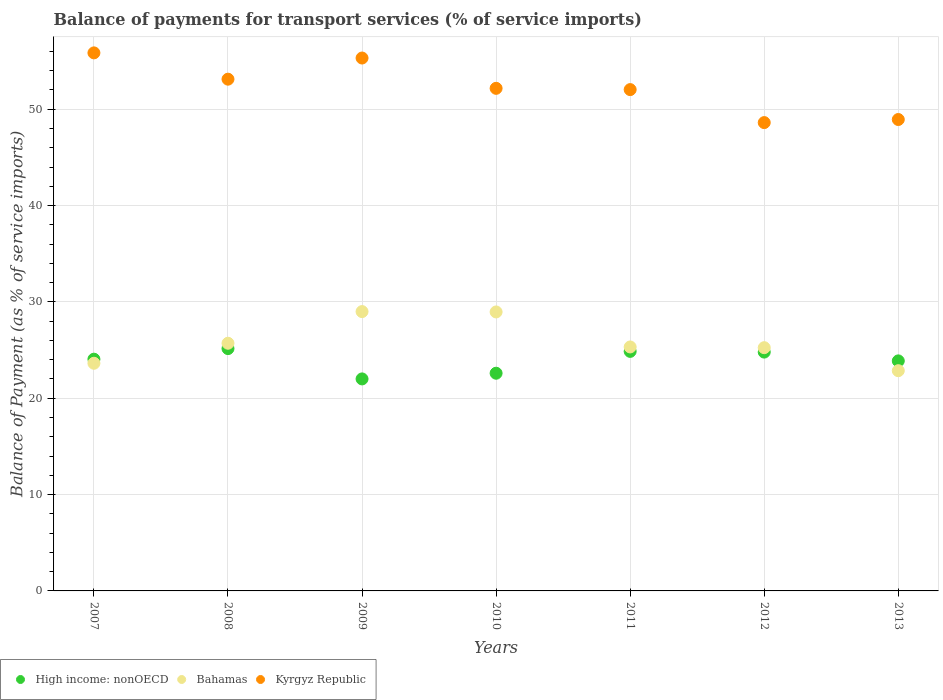How many different coloured dotlines are there?
Give a very brief answer. 3. Is the number of dotlines equal to the number of legend labels?
Your response must be concise. Yes. What is the balance of payments for transport services in Bahamas in 2007?
Offer a terse response. 23.63. Across all years, what is the maximum balance of payments for transport services in Bahamas?
Offer a very short reply. 29. Across all years, what is the minimum balance of payments for transport services in High income: nonOECD?
Provide a short and direct response. 22.01. In which year was the balance of payments for transport services in Kyrgyz Republic maximum?
Keep it short and to the point. 2007. What is the total balance of payments for transport services in Bahamas in the graph?
Your response must be concise. 180.73. What is the difference between the balance of payments for transport services in Bahamas in 2007 and that in 2011?
Your answer should be very brief. -1.69. What is the difference between the balance of payments for transport services in Bahamas in 2009 and the balance of payments for transport services in Kyrgyz Republic in 2012?
Offer a terse response. -19.62. What is the average balance of payments for transport services in Bahamas per year?
Your answer should be very brief. 25.82. In the year 2011, what is the difference between the balance of payments for transport services in High income: nonOECD and balance of payments for transport services in Kyrgyz Republic?
Your answer should be very brief. -27.17. In how many years, is the balance of payments for transport services in Bahamas greater than 16 %?
Keep it short and to the point. 7. What is the ratio of the balance of payments for transport services in Bahamas in 2007 to that in 2008?
Offer a terse response. 0.92. What is the difference between the highest and the second highest balance of payments for transport services in High income: nonOECD?
Offer a very short reply. 0.29. What is the difference between the highest and the lowest balance of payments for transport services in Kyrgyz Republic?
Your response must be concise. 7.24. In how many years, is the balance of payments for transport services in High income: nonOECD greater than the average balance of payments for transport services in High income: nonOECD taken over all years?
Make the answer very short. 4. Is the sum of the balance of payments for transport services in Kyrgyz Republic in 2008 and 2013 greater than the maximum balance of payments for transport services in High income: nonOECD across all years?
Offer a terse response. Yes. Is the balance of payments for transport services in Kyrgyz Republic strictly greater than the balance of payments for transport services in High income: nonOECD over the years?
Your response must be concise. Yes. Is the balance of payments for transport services in Kyrgyz Republic strictly less than the balance of payments for transport services in Bahamas over the years?
Your answer should be compact. No. How many dotlines are there?
Offer a terse response. 3. What is the difference between two consecutive major ticks on the Y-axis?
Give a very brief answer. 10. Are the values on the major ticks of Y-axis written in scientific E-notation?
Make the answer very short. No. Does the graph contain any zero values?
Give a very brief answer. No. Does the graph contain grids?
Keep it short and to the point. Yes. What is the title of the graph?
Your answer should be very brief. Balance of payments for transport services (% of service imports). What is the label or title of the Y-axis?
Make the answer very short. Balance of Payment (as % of service imports). What is the Balance of Payment (as % of service imports) in High income: nonOECD in 2007?
Offer a terse response. 24.06. What is the Balance of Payment (as % of service imports) in Bahamas in 2007?
Your response must be concise. 23.63. What is the Balance of Payment (as % of service imports) of Kyrgyz Republic in 2007?
Provide a short and direct response. 55.85. What is the Balance of Payment (as % of service imports) in High income: nonOECD in 2008?
Offer a terse response. 25.15. What is the Balance of Payment (as % of service imports) of Bahamas in 2008?
Your answer should be compact. 25.71. What is the Balance of Payment (as % of service imports) of Kyrgyz Republic in 2008?
Offer a terse response. 53.12. What is the Balance of Payment (as % of service imports) in High income: nonOECD in 2009?
Provide a short and direct response. 22.01. What is the Balance of Payment (as % of service imports) of Bahamas in 2009?
Provide a short and direct response. 29. What is the Balance of Payment (as % of service imports) in Kyrgyz Republic in 2009?
Make the answer very short. 55.32. What is the Balance of Payment (as % of service imports) of High income: nonOECD in 2010?
Give a very brief answer. 22.6. What is the Balance of Payment (as % of service imports) in Bahamas in 2010?
Make the answer very short. 28.96. What is the Balance of Payment (as % of service imports) in Kyrgyz Republic in 2010?
Your answer should be compact. 52.17. What is the Balance of Payment (as % of service imports) in High income: nonOECD in 2011?
Offer a very short reply. 24.86. What is the Balance of Payment (as % of service imports) in Bahamas in 2011?
Give a very brief answer. 25.32. What is the Balance of Payment (as % of service imports) in Kyrgyz Republic in 2011?
Make the answer very short. 52.04. What is the Balance of Payment (as % of service imports) in High income: nonOECD in 2012?
Your answer should be very brief. 24.79. What is the Balance of Payment (as % of service imports) of Bahamas in 2012?
Provide a short and direct response. 25.25. What is the Balance of Payment (as % of service imports) of Kyrgyz Republic in 2012?
Your response must be concise. 48.61. What is the Balance of Payment (as % of service imports) of High income: nonOECD in 2013?
Give a very brief answer. 23.88. What is the Balance of Payment (as % of service imports) in Bahamas in 2013?
Provide a short and direct response. 22.86. What is the Balance of Payment (as % of service imports) in Kyrgyz Republic in 2013?
Make the answer very short. 48.93. Across all years, what is the maximum Balance of Payment (as % of service imports) of High income: nonOECD?
Provide a succinct answer. 25.15. Across all years, what is the maximum Balance of Payment (as % of service imports) of Bahamas?
Your answer should be compact. 29. Across all years, what is the maximum Balance of Payment (as % of service imports) in Kyrgyz Republic?
Keep it short and to the point. 55.85. Across all years, what is the minimum Balance of Payment (as % of service imports) of High income: nonOECD?
Your answer should be very brief. 22.01. Across all years, what is the minimum Balance of Payment (as % of service imports) of Bahamas?
Your answer should be very brief. 22.86. Across all years, what is the minimum Balance of Payment (as % of service imports) in Kyrgyz Republic?
Provide a succinct answer. 48.61. What is the total Balance of Payment (as % of service imports) of High income: nonOECD in the graph?
Offer a terse response. 167.35. What is the total Balance of Payment (as % of service imports) of Bahamas in the graph?
Provide a succinct answer. 180.73. What is the total Balance of Payment (as % of service imports) of Kyrgyz Republic in the graph?
Offer a very short reply. 366.04. What is the difference between the Balance of Payment (as % of service imports) of High income: nonOECD in 2007 and that in 2008?
Provide a short and direct response. -1.1. What is the difference between the Balance of Payment (as % of service imports) in Bahamas in 2007 and that in 2008?
Provide a succinct answer. -2.08. What is the difference between the Balance of Payment (as % of service imports) of Kyrgyz Republic in 2007 and that in 2008?
Make the answer very short. 2.73. What is the difference between the Balance of Payment (as % of service imports) in High income: nonOECD in 2007 and that in 2009?
Your response must be concise. 2.05. What is the difference between the Balance of Payment (as % of service imports) of Bahamas in 2007 and that in 2009?
Offer a very short reply. -5.36. What is the difference between the Balance of Payment (as % of service imports) in Kyrgyz Republic in 2007 and that in 2009?
Provide a succinct answer. 0.53. What is the difference between the Balance of Payment (as % of service imports) in High income: nonOECD in 2007 and that in 2010?
Your answer should be compact. 1.46. What is the difference between the Balance of Payment (as % of service imports) in Bahamas in 2007 and that in 2010?
Provide a short and direct response. -5.33. What is the difference between the Balance of Payment (as % of service imports) in Kyrgyz Republic in 2007 and that in 2010?
Give a very brief answer. 3.68. What is the difference between the Balance of Payment (as % of service imports) in High income: nonOECD in 2007 and that in 2011?
Offer a terse response. -0.81. What is the difference between the Balance of Payment (as % of service imports) of Bahamas in 2007 and that in 2011?
Make the answer very short. -1.69. What is the difference between the Balance of Payment (as % of service imports) of Kyrgyz Republic in 2007 and that in 2011?
Provide a short and direct response. 3.81. What is the difference between the Balance of Payment (as % of service imports) of High income: nonOECD in 2007 and that in 2012?
Keep it short and to the point. -0.74. What is the difference between the Balance of Payment (as % of service imports) of Bahamas in 2007 and that in 2012?
Provide a short and direct response. -1.62. What is the difference between the Balance of Payment (as % of service imports) in Kyrgyz Republic in 2007 and that in 2012?
Keep it short and to the point. 7.24. What is the difference between the Balance of Payment (as % of service imports) of High income: nonOECD in 2007 and that in 2013?
Provide a short and direct response. 0.18. What is the difference between the Balance of Payment (as % of service imports) of Bahamas in 2007 and that in 2013?
Your answer should be compact. 0.77. What is the difference between the Balance of Payment (as % of service imports) of Kyrgyz Republic in 2007 and that in 2013?
Give a very brief answer. 6.92. What is the difference between the Balance of Payment (as % of service imports) in High income: nonOECD in 2008 and that in 2009?
Your answer should be compact. 3.15. What is the difference between the Balance of Payment (as % of service imports) in Bahamas in 2008 and that in 2009?
Ensure brevity in your answer.  -3.29. What is the difference between the Balance of Payment (as % of service imports) of Kyrgyz Republic in 2008 and that in 2009?
Offer a terse response. -2.19. What is the difference between the Balance of Payment (as % of service imports) in High income: nonOECD in 2008 and that in 2010?
Offer a terse response. 2.56. What is the difference between the Balance of Payment (as % of service imports) of Bahamas in 2008 and that in 2010?
Ensure brevity in your answer.  -3.25. What is the difference between the Balance of Payment (as % of service imports) of Kyrgyz Republic in 2008 and that in 2010?
Your answer should be compact. 0.95. What is the difference between the Balance of Payment (as % of service imports) of High income: nonOECD in 2008 and that in 2011?
Give a very brief answer. 0.29. What is the difference between the Balance of Payment (as % of service imports) in Bahamas in 2008 and that in 2011?
Your answer should be compact. 0.39. What is the difference between the Balance of Payment (as % of service imports) in Kyrgyz Republic in 2008 and that in 2011?
Keep it short and to the point. 1.08. What is the difference between the Balance of Payment (as % of service imports) of High income: nonOECD in 2008 and that in 2012?
Provide a short and direct response. 0.36. What is the difference between the Balance of Payment (as % of service imports) of Bahamas in 2008 and that in 2012?
Give a very brief answer. 0.46. What is the difference between the Balance of Payment (as % of service imports) in Kyrgyz Republic in 2008 and that in 2012?
Provide a short and direct response. 4.51. What is the difference between the Balance of Payment (as % of service imports) in High income: nonOECD in 2008 and that in 2013?
Provide a short and direct response. 1.27. What is the difference between the Balance of Payment (as % of service imports) in Bahamas in 2008 and that in 2013?
Your answer should be compact. 2.85. What is the difference between the Balance of Payment (as % of service imports) of Kyrgyz Republic in 2008 and that in 2013?
Keep it short and to the point. 4.19. What is the difference between the Balance of Payment (as % of service imports) of High income: nonOECD in 2009 and that in 2010?
Provide a succinct answer. -0.59. What is the difference between the Balance of Payment (as % of service imports) in Bahamas in 2009 and that in 2010?
Make the answer very short. 0.04. What is the difference between the Balance of Payment (as % of service imports) in Kyrgyz Republic in 2009 and that in 2010?
Offer a terse response. 3.15. What is the difference between the Balance of Payment (as % of service imports) of High income: nonOECD in 2009 and that in 2011?
Your response must be concise. -2.86. What is the difference between the Balance of Payment (as % of service imports) of Bahamas in 2009 and that in 2011?
Give a very brief answer. 3.67. What is the difference between the Balance of Payment (as % of service imports) of Kyrgyz Republic in 2009 and that in 2011?
Offer a terse response. 3.28. What is the difference between the Balance of Payment (as % of service imports) of High income: nonOECD in 2009 and that in 2012?
Your answer should be very brief. -2.78. What is the difference between the Balance of Payment (as % of service imports) of Bahamas in 2009 and that in 2012?
Provide a short and direct response. 3.75. What is the difference between the Balance of Payment (as % of service imports) of Kyrgyz Republic in 2009 and that in 2012?
Ensure brevity in your answer.  6.7. What is the difference between the Balance of Payment (as % of service imports) of High income: nonOECD in 2009 and that in 2013?
Keep it short and to the point. -1.87. What is the difference between the Balance of Payment (as % of service imports) of Bahamas in 2009 and that in 2013?
Provide a short and direct response. 6.14. What is the difference between the Balance of Payment (as % of service imports) of Kyrgyz Republic in 2009 and that in 2013?
Ensure brevity in your answer.  6.38. What is the difference between the Balance of Payment (as % of service imports) in High income: nonOECD in 2010 and that in 2011?
Your answer should be compact. -2.27. What is the difference between the Balance of Payment (as % of service imports) in Bahamas in 2010 and that in 2011?
Keep it short and to the point. 3.63. What is the difference between the Balance of Payment (as % of service imports) of Kyrgyz Republic in 2010 and that in 2011?
Keep it short and to the point. 0.13. What is the difference between the Balance of Payment (as % of service imports) of High income: nonOECD in 2010 and that in 2012?
Your answer should be compact. -2.19. What is the difference between the Balance of Payment (as % of service imports) in Bahamas in 2010 and that in 2012?
Your response must be concise. 3.71. What is the difference between the Balance of Payment (as % of service imports) of Kyrgyz Republic in 2010 and that in 2012?
Your answer should be compact. 3.56. What is the difference between the Balance of Payment (as % of service imports) of High income: nonOECD in 2010 and that in 2013?
Provide a succinct answer. -1.28. What is the difference between the Balance of Payment (as % of service imports) of Bahamas in 2010 and that in 2013?
Ensure brevity in your answer.  6.1. What is the difference between the Balance of Payment (as % of service imports) of Kyrgyz Republic in 2010 and that in 2013?
Make the answer very short. 3.24. What is the difference between the Balance of Payment (as % of service imports) in High income: nonOECD in 2011 and that in 2012?
Your answer should be very brief. 0.07. What is the difference between the Balance of Payment (as % of service imports) in Bahamas in 2011 and that in 2012?
Provide a short and direct response. 0.08. What is the difference between the Balance of Payment (as % of service imports) of Kyrgyz Republic in 2011 and that in 2012?
Keep it short and to the point. 3.43. What is the difference between the Balance of Payment (as % of service imports) in High income: nonOECD in 2011 and that in 2013?
Provide a succinct answer. 0.99. What is the difference between the Balance of Payment (as % of service imports) in Bahamas in 2011 and that in 2013?
Provide a succinct answer. 2.46. What is the difference between the Balance of Payment (as % of service imports) of Kyrgyz Republic in 2011 and that in 2013?
Make the answer very short. 3.1. What is the difference between the Balance of Payment (as % of service imports) in High income: nonOECD in 2012 and that in 2013?
Your answer should be compact. 0.91. What is the difference between the Balance of Payment (as % of service imports) in Bahamas in 2012 and that in 2013?
Offer a very short reply. 2.39. What is the difference between the Balance of Payment (as % of service imports) of Kyrgyz Republic in 2012 and that in 2013?
Give a very brief answer. -0.32. What is the difference between the Balance of Payment (as % of service imports) in High income: nonOECD in 2007 and the Balance of Payment (as % of service imports) in Bahamas in 2008?
Make the answer very short. -1.65. What is the difference between the Balance of Payment (as % of service imports) in High income: nonOECD in 2007 and the Balance of Payment (as % of service imports) in Kyrgyz Republic in 2008?
Provide a succinct answer. -29.07. What is the difference between the Balance of Payment (as % of service imports) of Bahamas in 2007 and the Balance of Payment (as % of service imports) of Kyrgyz Republic in 2008?
Make the answer very short. -29.49. What is the difference between the Balance of Payment (as % of service imports) in High income: nonOECD in 2007 and the Balance of Payment (as % of service imports) in Bahamas in 2009?
Keep it short and to the point. -4.94. What is the difference between the Balance of Payment (as % of service imports) in High income: nonOECD in 2007 and the Balance of Payment (as % of service imports) in Kyrgyz Republic in 2009?
Provide a short and direct response. -31.26. What is the difference between the Balance of Payment (as % of service imports) in Bahamas in 2007 and the Balance of Payment (as % of service imports) in Kyrgyz Republic in 2009?
Your answer should be very brief. -31.68. What is the difference between the Balance of Payment (as % of service imports) of High income: nonOECD in 2007 and the Balance of Payment (as % of service imports) of Bahamas in 2010?
Provide a short and direct response. -4.9. What is the difference between the Balance of Payment (as % of service imports) of High income: nonOECD in 2007 and the Balance of Payment (as % of service imports) of Kyrgyz Republic in 2010?
Provide a short and direct response. -28.11. What is the difference between the Balance of Payment (as % of service imports) of Bahamas in 2007 and the Balance of Payment (as % of service imports) of Kyrgyz Republic in 2010?
Ensure brevity in your answer.  -28.54. What is the difference between the Balance of Payment (as % of service imports) in High income: nonOECD in 2007 and the Balance of Payment (as % of service imports) in Bahamas in 2011?
Your response must be concise. -1.27. What is the difference between the Balance of Payment (as % of service imports) of High income: nonOECD in 2007 and the Balance of Payment (as % of service imports) of Kyrgyz Republic in 2011?
Keep it short and to the point. -27.98. What is the difference between the Balance of Payment (as % of service imports) of Bahamas in 2007 and the Balance of Payment (as % of service imports) of Kyrgyz Republic in 2011?
Ensure brevity in your answer.  -28.41. What is the difference between the Balance of Payment (as % of service imports) in High income: nonOECD in 2007 and the Balance of Payment (as % of service imports) in Bahamas in 2012?
Make the answer very short. -1.19. What is the difference between the Balance of Payment (as % of service imports) in High income: nonOECD in 2007 and the Balance of Payment (as % of service imports) in Kyrgyz Republic in 2012?
Make the answer very short. -24.56. What is the difference between the Balance of Payment (as % of service imports) in Bahamas in 2007 and the Balance of Payment (as % of service imports) in Kyrgyz Republic in 2012?
Your answer should be compact. -24.98. What is the difference between the Balance of Payment (as % of service imports) in High income: nonOECD in 2007 and the Balance of Payment (as % of service imports) in Bahamas in 2013?
Give a very brief answer. 1.19. What is the difference between the Balance of Payment (as % of service imports) of High income: nonOECD in 2007 and the Balance of Payment (as % of service imports) of Kyrgyz Republic in 2013?
Ensure brevity in your answer.  -24.88. What is the difference between the Balance of Payment (as % of service imports) of Bahamas in 2007 and the Balance of Payment (as % of service imports) of Kyrgyz Republic in 2013?
Keep it short and to the point. -25.3. What is the difference between the Balance of Payment (as % of service imports) in High income: nonOECD in 2008 and the Balance of Payment (as % of service imports) in Bahamas in 2009?
Offer a very short reply. -3.84. What is the difference between the Balance of Payment (as % of service imports) in High income: nonOECD in 2008 and the Balance of Payment (as % of service imports) in Kyrgyz Republic in 2009?
Make the answer very short. -30.16. What is the difference between the Balance of Payment (as % of service imports) in Bahamas in 2008 and the Balance of Payment (as % of service imports) in Kyrgyz Republic in 2009?
Offer a terse response. -29.61. What is the difference between the Balance of Payment (as % of service imports) in High income: nonOECD in 2008 and the Balance of Payment (as % of service imports) in Bahamas in 2010?
Offer a very short reply. -3.81. What is the difference between the Balance of Payment (as % of service imports) of High income: nonOECD in 2008 and the Balance of Payment (as % of service imports) of Kyrgyz Republic in 2010?
Offer a terse response. -27.02. What is the difference between the Balance of Payment (as % of service imports) in Bahamas in 2008 and the Balance of Payment (as % of service imports) in Kyrgyz Republic in 2010?
Offer a terse response. -26.46. What is the difference between the Balance of Payment (as % of service imports) of High income: nonOECD in 2008 and the Balance of Payment (as % of service imports) of Bahamas in 2011?
Offer a very short reply. -0.17. What is the difference between the Balance of Payment (as % of service imports) in High income: nonOECD in 2008 and the Balance of Payment (as % of service imports) in Kyrgyz Republic in 2011?
Your answer should be very brief. -26.89. What is the difference between the Balance of Payment (as % of service imports) in Bahamas in 2008 and the Balance of Payment (as % of service imports) in Kyrgyz Republic in 2011?
Your answer should be very brief. -26.33. What is the difference between the Balance of Payment (as % of service imports) in High income: nonOECD in 2008 and the Balance of Payment (as % of service imports) in Bahamas in 2012?
Your answer should be very brief. -0.1. What is the difference between the Balance of Payment (as % of service imports) in High income: nonOECD in 2008 and the Balance of Payment (as % of service imports) in Kyrgyz Republic in 2012?
Provide a succinct answer. -23.46. What is the difference between the Balance of Payment (as % of service imports) in Bahamas in 2008 and the Balance of Payment (as % of service imports) in Kyrgyz Republic in 2012?
Provide a succinct answer. -22.9. What is the difference between the Balance of Payment (as % of service imports) in High income: nonOECD in 2008 and the Balance of Payment (as % of service imports) in Bahamas in 2013?
Offer a terse response. 2.29. What is the difference between the Balance of Payment (as % of service imports) of High income: nonOECD in 2008 and the Balance of Payment (as % of service imports) of Kyrgyz Republic in 2013?
Offer a very short reply. -23.78. What is the difference between the Balance of Payment (as % of service imports) in Bahamas in 2008 and the Balance of Payment (as % of service imports) in Kyrgyz Republic in 2013?
Provide a short and direct response. -23.22. What is the difference between the Balance of Payment (as % of service imports) of High income: nonOECD in 2009 and the Balance of Payment (as % of service imports) of Bahamas in 2010?
Your answer should be compact. -6.95. What is the difference between the Balance of Payment (as % of service imports) in High income: nonOECD in 2009 and the Balance of Payment (as % of service imports) in Kyrgyz Republic in 2010?
Provide a succinct answer. -30.16. What is the difference between the Balance of Payment (as % of service imports) of Bahamas in 2009 and the Balance of Payment (as % of service imports) of Kyrgyz Republic in 2010?
Provide a short and direct response. -23.17. What is the difference between the Balance of Payment (as % of service imports) of High income: nonOECD in 2009 and the Balance of Payment (as % of service imports) of Bahamas in 2011?
Provide a succinct answer. -3.32. What is the difference between the Balance of Payment (as % of service imports) of High income: nonOECD in 2009 and the Balance of Payment (as % of service imports) of Kyrgyz Republic in 2011?
Keep it short and to the point. -30.03. What is the difference between the Balance of Payment (as % of service imports) in Bahamas in 2009 and the Balance of Payment (as % of service imports) in Kyrgyz Republic in 2011?
Provide a succinct answer. -23.04. What is the difference between the Balance of Payment (as % of service imports) of High income: nonOECD in 2009 and the Balance of Payment (as % of service imports) of Bahamas in 2012?
Keep it short and to the point. -3.24. What is the difference between the Balance of Payment (as % of service imports) of High income: nonOECD in 2009 and the Balance of Payment (as % of service imports) of Kyrgyz Republic in 2012?
Offer a terse response. -26.61. What is the difference between the Balance of Payment (as % of service imports) of Bahamas in 2009 and the Balance of Payment (as % of service imports) of Kyrgyz Republic in 2012?
Make the answer very short. -19.62. What is the difference between the Balance of Payment (as % of service imports) of High income: nonOECD in 2009 and the Balance of Payment (as % of service imports) of Bahamas in 2013?
Ensure brevity in your answer.  -0.85. What is the difference between the Balance of Payment (as % of service imports) in High income: nonOECD in 2009 and the Balance of Payment (as % of service imports) in Kyrgyz Republic in 2013?
Give a very brief answer. -26.93. What is the difference between the Balance of Payment (as % of service imports) in Bahamas in 2009 and the Balance of Payment (as % of service imports) in Kyrgyz Republic in 2013?
Offer a very short reply. -19.94. What is the difference between the Balance of Payment (as % of service imports) in High income: nonOECD in 2010 and the Balance of Payment (as % of service imports) in Bahamas in 2011?
Give a very brief answer. -2.73. What is the difference between the Balance of Payment (as % of service imports) in High income: nonOECD in 2010 and the Balance of Payment (as % of service imports) in Kyrgyz Republic in 2011?
Ensure brevity in your answer.  -29.44. What is the difference between the Balance of Payment (as % of service imports) in Bahamas in 2010 and the Balance of Payment (as % of service imports) in Kyrgyz Republic in 2011?
Your response must be concise. -23.08. What is the difference between the Balance of Payment (as % of service imports) of High income: nonOECD in 2010 and the Balance of Payment (as % of service imports) of Bahamas in 2012?
Keep it short and to the point. -2.65. What is the difference between the Balance of Payment (as % of service imports) in High income: nonOECD in 2010 and the Balance of Payment (as % of service imports) in Kyrgyz Republic in 2012?
Your answer should be compact. -26.02. What is the difference between the Balance of Payment (as % of service imports) of Bahamas in 2010 and the Balance of Payment (as % of service imports) of Kyrgyz Republic in 2012?
Ensure brevity in your answer.  -19.66. What is the difference between the Balance of Payment (as % of service imports) in High income: nonOECD in 2010 and the Balance of Payment (as % of service imports) in Bahamas in 2013?
Provide a short and direct response. -0.26. What is the difference between the Balance of Payment (as % of service imports) of High income: nonOECD in 2010 and the Balance of Payment (as % of service imports) of Kyrgyz Republic in 2013?
Offer a very short reply. -26.34. What is the difference between the Balance of Payment (as % of service imports) in Bahamas in 2010 and the Balance of Payment (as % of service imports) in Kyrgyz Republic in 2013?
Provide a short and direct response. -19.98. What is the difference between the Balance of Payment (as % of service imports) in High income: nonOECD in 2011 and the Balance of Payment (as % of service imports) in Bahamas in 2012?
Make the answer very short. -0.39. What is the difference between the Balance of Payment (as % of service imports) in High income: nonOECD in 2011 and the Balance of Payment (as % of service imports) in Kyrgyz Republic in 2012?
Provide a short and direct response. -23.75. What is the difference between the Balance of Payment (as % of service imports) of Bahamas in 2011 and the Balance of Payment (as % of service imports) of Kyrgyz Republic in 2012?
Give a very brief answer. -23.29. What is the difference between the Balance of Payment (as % of service imports) in High income: nonOECD in 2011 and the Balance of Payment (as % of service imports) in Bahamas in 2013?
Keep it short and to the point. 2. What is the difference between the Balance of Payment (as % of service imports) of High income: nonOECD in 2011 and the Balance of Payment (as % of service imports) of Kyrgyz Republic in 2013?
Offer a very short reply. -24.07. What is the difference between the Balance of Payment (as % of service imports) in Bahamas in 2011 and the Balance of Payment (as % of service imports) in Kyrgyz Republic in 2013?
Your answer should be very brief. -23.61. What is the difference between the Balance of Payment (as % of service imports) in High income: nonOECD in 2012 and the Balance of Payment (as % of service imports) in Bahamas in 2013?
Provide a short and direct response. 1.93. What is the difference between the Balance of Payment (as % of service imports) in High income: nonOECD in 2012 and the Balance of Payment (as % of service imports) in Kyrgyz Republic in 2013?
Make the answer very short. -24.14. What is the difference between the Balance of Payment (as % of service imports) in Bahamas in 2012 and the Balance of Payment (as % of service imports) in Kyrgyz Republic in 2013?
Provide a short and direct response. -23.68. What is the average Balance of Payment (as % of service imports) in High income: nonOECD per year?
Keep it short and to the point. 23.91. What is the average Balance of Payment (as % of service imports) in Bahamas per year?
Your answer should be very brief. 25.82. What is the average Balance of Payment (as % of service imports) of Kyrgyz Republic per year?
Make the answer very short. 52.29. In the year 2007, what is the difference between the Balance of Payment (as % of service imports) in High income: nonOECD and Balance of Payment (as % of service imports) in Bahamas?
Make the answer very short. 0.42. In the year 2007, what is the difference between the Balance of Payment (as % of service imports) in High income: nonOECD and Balance of Payment (as % of service imports) in Kyrgyz Republic?
Your answer should be very brief. -31.8. In the year 2007, what is the difference between the Balance of Payment (as % of service imports) of Bahamas and Balance of Payment (as % of service imports) of Kyrgyz Republic?
Make the answer very short. -32.22. In the year 2008, what is the difference between the Balance of Payment (as % of service imports) of High income: nonOECD and Balance of Payment (as % of service imports) of Bahamas?
Offer a terse response. -0.56. In the year 2008, what is the difference between the Balance of Payment (as % of service imports) in High income: nonOECD and Balance of Payment (as % of service imports) in Kyrgyz Republic?
Provide a short and direct response. -27.97. In the year 2008, what is the difference between the Balance of Payment (as % of service imports) of Bahamas and Balance of Payment (as % of service imports) of Kyrgyz Republic?
Keep it short and to the point. -27.41. In the year 2009, what is the difference between the Balance of Payment (as % of service imports) of High income: nonOECD and Balance of Payment (as % of service imports) of Bahamas?
Your answer should be compact. -6.99. In the year 2009, what is the difference between the Balance of Payment (as % of service imports) in High income: nonOECD and Balance of Payment (as % of service imports) in Kyrgyz Republic?
Offer a terse response. -33.31. In the year 2009, what is the difference between the Balance of Payment (as % of service imports) of Bahamas and Balance of Payment (as % of service imports) of Kyrgyz Republic?
Provide a short and direct response. -26.32. In the year 2010, what is the difference between the Balance of Payment (as % of service imports) of High income: nonOECD and Balance of Payment (as % of service imports) of Bahamas?
Give a very brief answer. -6.36. In the year 2010, what is the difference between the Balance of Payment (as % of service imports) of High income: nonOECD and Balance of Payment (as % of service imports) of Kyrgyz Republic?
Keep it short and to the point. -29.57. In the year 2010, what is the difference between the Balance of Payment (as % of service imports) of Bahamas and Balance of Payment (as % of service imports) of Kyrgyz Republic?
Ensure brevity in your answer.  -23.21. In the year 2011, what is the difference between the Balance of Payment (as % of service imports) in High income: nonOECD and Balance of Payment (as % of service imports) in Bahamas?
Provide a succinct answer. -0.46. In the year 2011, what is the difference between the Balance of Payment (as % of service imports) of High income: nonOECD and Balance of Payment (as % of service imports) of Kyrgyz Republic?
Your response must be concise. -27.17. In the year 2011, what is the difference between the Balance of Payment (as % of service imports) in Bahamas and Balance of Payment (as % of service imports) in Kyrgyz Republic?
Keep it short and to the point. -26.71. In the year 2012, what is the difference between the Balance of Payment (as % of service imports) in High income: nonOECD and Balance of Payment (as % of service imports) in Bahamas?
Keep it short and to the point. -0.46. In the year 2012, what is the difference between the Balance of Payment (as % of service imports) in High income: nonOECD and Balance of Payment (as % of service imports) in Kyrgyz Republic?
Ensure brevity in your answer.  -23.82. In the year 2012, what is the difference between the Balance of Payment (as % of service imports) in Bahamas and Balance of Payment (as % of service imports) in Kyrgyz Republic?
Offer a terse response. -23.36. In the year 2013, what is the difference between the Balance of Payment (as % of service imports) of High income: nonOECD and Balance of Payment (as % of service imports) of Bahamas?
Provide a short and direct response. 1.02. In the year 2013, what is the difference between the Balance of Payment (as % of service imports) in High income: nonOECD and Balance of Payment (as % of service imports) in Kyrgyz Republic?
Ensure brevity in your answer.  -25.06. In the year 2013, what is the difference between the Balance of Payment (as % of service imports) in Bahamas and Balance of Payment (as % of service imports) in Kyrgyz Republic?
Provide a short and direct response. -26.07. What is the ratio of the Balance of Payment (as % of service imports) of High income: nonOECD in 2007 to that in 2008?
Make the answer very short. 0.96. What is the ratio of the Balance of Payment (as % of service imports) in Bahamas in 2007 to that in 2008?
Make the answer very short. 0.92. What is the ratio of the Balance of Payment (as % of service imports) in Kyrgyz Republic in 2007 to that in 2008?
Your answer should be compact. 1.05. What is the ratio of the Balance of Payment (as % of service imports) of High income: nonOECD in 2007 to that in 2009?
Give a very brief answer. 1.09. What is the ratio of the Balance of Payment (as % of service imports) in Bahamas in 2007 to that in 2009?
Your answer should be compact. 0.81. What is the ratio of the Balance of Payment (as % of service imports) of Kyrgyz Republic in 2007 to that in 2009?
Your response must be concise. 1.01. What is the ratio of the Balance of Payment (as % of service imports) of High income: nonOECD in 2007 to that in 2010?
Offer a terse response. 1.06. What is the ratio of the Balance of Payment (as % of service imports) in Bahamas in 2007 to that in 2010?
Provide a short and direct response. 0.82. What is the ratio of the Balance of Payment (as % of service imports) in Kyrgyz Republic in 2007 to that in 2010?
Your answer should be very brief. 1.07. What is the ratio of the Balance of Payment (as % of service imports) in High income: nonOECD in 2007 to that in 2011?
Keep it short and to the point. 0.97. What is the ratio of the Balance of Payment (as % of service imports) of Bahamas in 2007 to that in 2011?
Ensure brevity in your answer.  0.93. What is the ratio of the Balance of Payment (as % of service imports) of Kyrgyz Republic in 2007 to that in 2011?
Offer a very short reply. 1.07. What is the ratio of the Balance of Payment (as % of service imports) in High income: nonOECD in 2007 to that in 2012?
Provide a succinct answer. 0.97. What is the ratio of the Balance of Payment (as % of service imports) of Bahamas in 2007 to that in 2012?
Ensure brevity in your answer.  0.94. What is the ratio of the Balance of Payment (as % of service imports) in Kyrgyz Republic in 2007 to that in 2012?
Provide a succinct answer. 1.15. What is the ratio of the Balance of Payment (as % of service imports) in High income: nonOECD in 2007 to that in 2013?
Make the answer very short. 1.01. What is the ratio of the Balance of Payment (as % of service imports) in Bahamas in 2007 to that in 2013?
Your answer should be compact. 1.03. What is the ratio of the Balance of Payment (as % of service imports) of Kyrgyz Republic in 2007 to that in 2013?
Keep it short and to the point. 1.14. What is the ratio of the Balance of Payment (as % of service imports) in High income: nonOECD in 2008 to that in 2009?
Provide a succinct answer. 1.14. What is the ratio of the Balance of Payment (as % of service imports) of Bahamas in 2008 to that in 2009?
Ensure brevity in your answer.  0.89. What is the ratio of the Balance of Payment (as % of service imports) in Kyrgyz Republic in 2008 to that in 2009?
Ensure brevity in your answer.  0.96. What is the ratio of the Balance of Payment (as % of service imports) in High income: nonOECD in 2008 to that in 2010?
Ensure brevity in your answer.  1.11. What is the ratio of the Balance of Payment (as % of service imports) of Bahamas in 2008 to that in 2010?
Ensure brevity in your answer.  0.89. What is the ratio of the Balance of Payment (as % of service imports) in Kyrgyz Republic in 2008 to that in 2010?
Keep it short and to the point. 1.02. What is the ratio of the Balance of Payment (as % of service imports) of High income: nonOECD in 2008 to that in 2011?
Ensure brevity in your answer.  1.01. What is the ratio of the Balance of Payment (as % of service imports) in Bahamas in 2008 to that in 2011?
Your answer should be very brief. 1.02. What is the ratio of the Balance of Payment (as % of service imports) of Kyrgyz Republic in 2008 to that in 2011?
Your answer should be compact. 1.02. What is the ratio of the Balance of Payment (as % of service imports) of High income: nonOECD in 2008 to that in 2012?
Give a very brief answer. 1.01. What is the ratio of the Balance of Payment (as % of service imports) of Bahamas in 2008 to that in 2012?
Ensure brevity in your answer.  1.02. What is the ratio of the Balance of Payment (as % of service imports) in Kyrgyz Republic in 2008 to that in 2012?
Provide a succinct answer. 1.09. What is the ratio of the Balance of Payment (as % of service imports) in High income: nonOECD in 2008 to that in 2013?
Make the answer very short. 1.05. What is the ratio of the Balance of Payment (as % of service imports) in Bahamas in 2008 to that in 2013?
Offer a very short reply. 1.12. What is the ratio of the Balance of Payment (as % of service imports) in Kyrgyz Republic in 2008 to that in 2013?
Your answer should be very brief. 1.09. What is the ratio of the Balance of Payment (as % of service imports) of High income: nonOECD in 2009 to that in 2010?
Keep it short and to the point. 0.97. What is the ratio of the Balance of Payment (as % of service imports) in Bahamas in 2009 to that in 2010?
Provide a succinct answer. 1. What is the ratio of the Balance of Payment (as % of service imports) in Kyrgyz Republic in 2009 to that in 2010?
Give a very brief answer. 1.06. What is the ratio of the Balance of Payment (as % of service imports) of High income: nonOECD in 2009 to that in 2011?
Give a very brief answer. 0.89. What is the ratio of the Balance of Payment (as % of service imports) of Bahamas in 2009 to that in 2011?
Ensure brevity in your answer.  1.15. What is the ratio of the Balance of Payment (as % of service imports) of Kyrgyz Republic in 2009 to that in 2011?
Provide a short and direct response. 1.06. What is the ratio of the Balance of Payment (as % of service imports) in High income: nonOECD in 2009 to that in 2012?
Keep it short and to the point. 0.89. What is the ratio of the Balance of Payment (as % of service imports) in Bahamas in 2009 to that in 2012?
Give a very brief answer. 1.15. What is the ratio of the Balance of Payment (as % of service imports) of Kyrgyz Republic in 2009 to that in 2012?
Give a very brief answer. 1.14. What is the ratio of the Balance of Payment (as % of service imports) of High income: nonOECD in 2009 to that in 2013?
Give a very brief answer. 0.92. What is the ratio of the Balance of Payment (as % of service imports) in Bahamas in 2009 to that in 2013?
Your answer should be compact. 1.27. What is the ratio of the Balance of Payment (as % of service imports) of Kyrgyz Republic in 2009 to that in 2013?
Offer a very short reply. 1.13. What is the ratio of the Balance of Payment (as % of service imports) in High income: nonOECD in 2010 to that in 2011?
Make the answer very short. 0.91. What is the ratio of the Balance of Payment (as % of service imports) in Bahamas in 2010 to that in 2011?
Make the answer very short. 1.14. What is the ratio of the Balance of Payment (as % of service imports) of Kyrgyz Republic in 2010 to that in 2011?
Give a very brief answer. 1. What is the ratio of the Balance of Payment (as % of service imports) in High income: nonOECD in 2010 to that in 2012?
Your answer should be very brief. 0.91. What is the ratio of the Balance of Payment (as % of service imports) of Bahamas in 2010 to that in 2012?
Offer a very short reply. 1.15. What is the ratio of the Balance of Payment (as % of service imports) of Kyrgyz Republic in 2010 to that in 2012?
Make the answer very short. 1.07. What is the ratio of the Balance of Payment (as % of service imports) of High income: nonOECD in 2010 to that in 2013?
Provide a short and direct response. 0.95. What is the ratio of the Balance of Payment (as % of service imports) in Bahamas in 2010 to that in 2013?
Offer a terse response. 1.27. What is the ratio of the Balance of Payment (as % of service imports) of Kyrgyz Republic in 2010 to that in 2013?
Provide a succinct answer. 1.07. What is the ratio of the Balance of Payment (as % of service imports) in Kyrgyz Republic in 2011 to that in 2012?
Ensure brevity in your answer.  1.07. What is the ratio of the Balance of Payment (as % of service imports) of High income: nonOECD in 2011 to that in 2013?
Keep it short and to the point. 1.04. What is the ratio of the Balance of Payment (as % of service imports) in Bahamas in 2011 to that in 2013?
Your answer should be very brief. 1.11. What is the ratio of the Balance of Payment (as % of service imports) in Kyrgyz Republic in 2011 to that in 2013?
Your response must be concise. 1.06. What is the ratio of the Balance of Payment (as % of service imports) of High income: nonOECD in 2012 to that in 2013?
Your answer should be very brief. 1.04. What is the ratio of the Balance of Payment (as % of service imports) of Bahamas in 2012 to that in 2013?
Offer a very short reply. 1.1. What is the difference between the highest and the second highest Balance of Payment (as % of service imports) of High income: nonOECD?
Keep it short and to the point. 0.29. What is the difference between the highest and the second highest Balance of Payment (as % of service imports) in Bahamas?
Make the answer very short. 0.04. What is the difference between the highest and the second highest Balance of Payment (as % of service imports) of Kyrgyz Republic?
Your response must be concise. 0.53. What is the difference between the highest and the lowest Balance of Payment (as % of service imports) of High income: nonOECD?
Keep it short and to the point. 3.15. What is the difference between the highest and the lowest Balance of Payment (as % of service imports) in Bahamas?
Offer a very short reply. 6.14. What is the difference between the highest and the lowest Balance of Payment (as % of service imports) of Kyrgyz Republic?
Give a very brief answer. 7.24. 